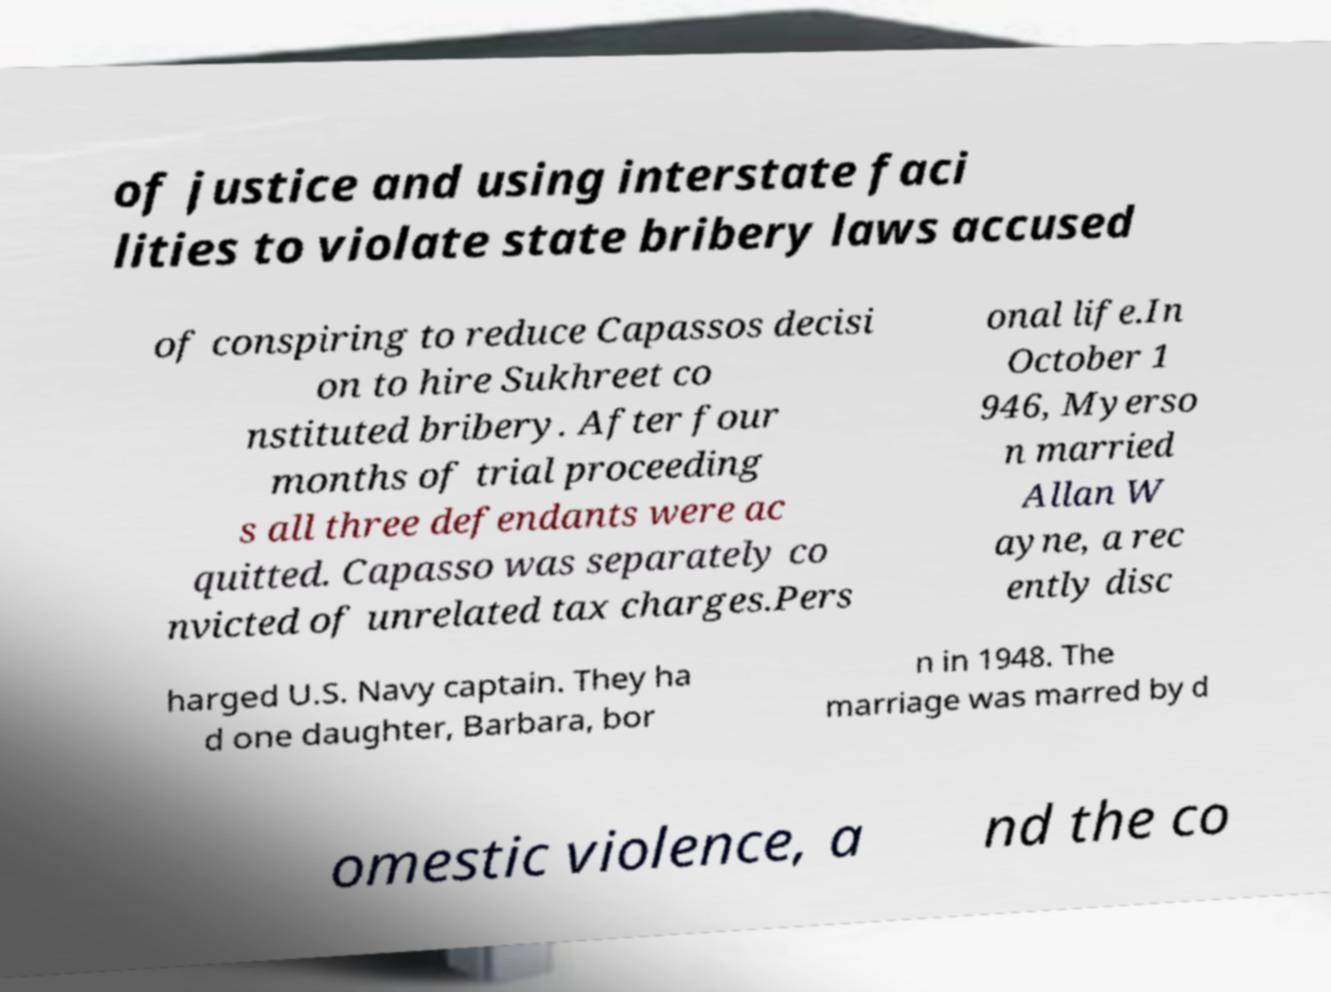What messages or text are displayed in this image? I need them in a readable, typed format. of justice and using interstate faci lities to violate state bribery laws accused of conspiring to reduce Capassos decisi on to hire Sukhreet co nstituted bribery. After four months of trial proceeding s all three defendants were ac quitted. Capasso was separately co nvicted of unrelated tax charges.Pers onal life.In October 1 946, Myerso n married Allan W ayne, a rec ently disc harged U.S. Navy captain. They ha d one daughter, Barbara, bor n in 1948. The marriage was marred by d omestic violence, a nd the co 